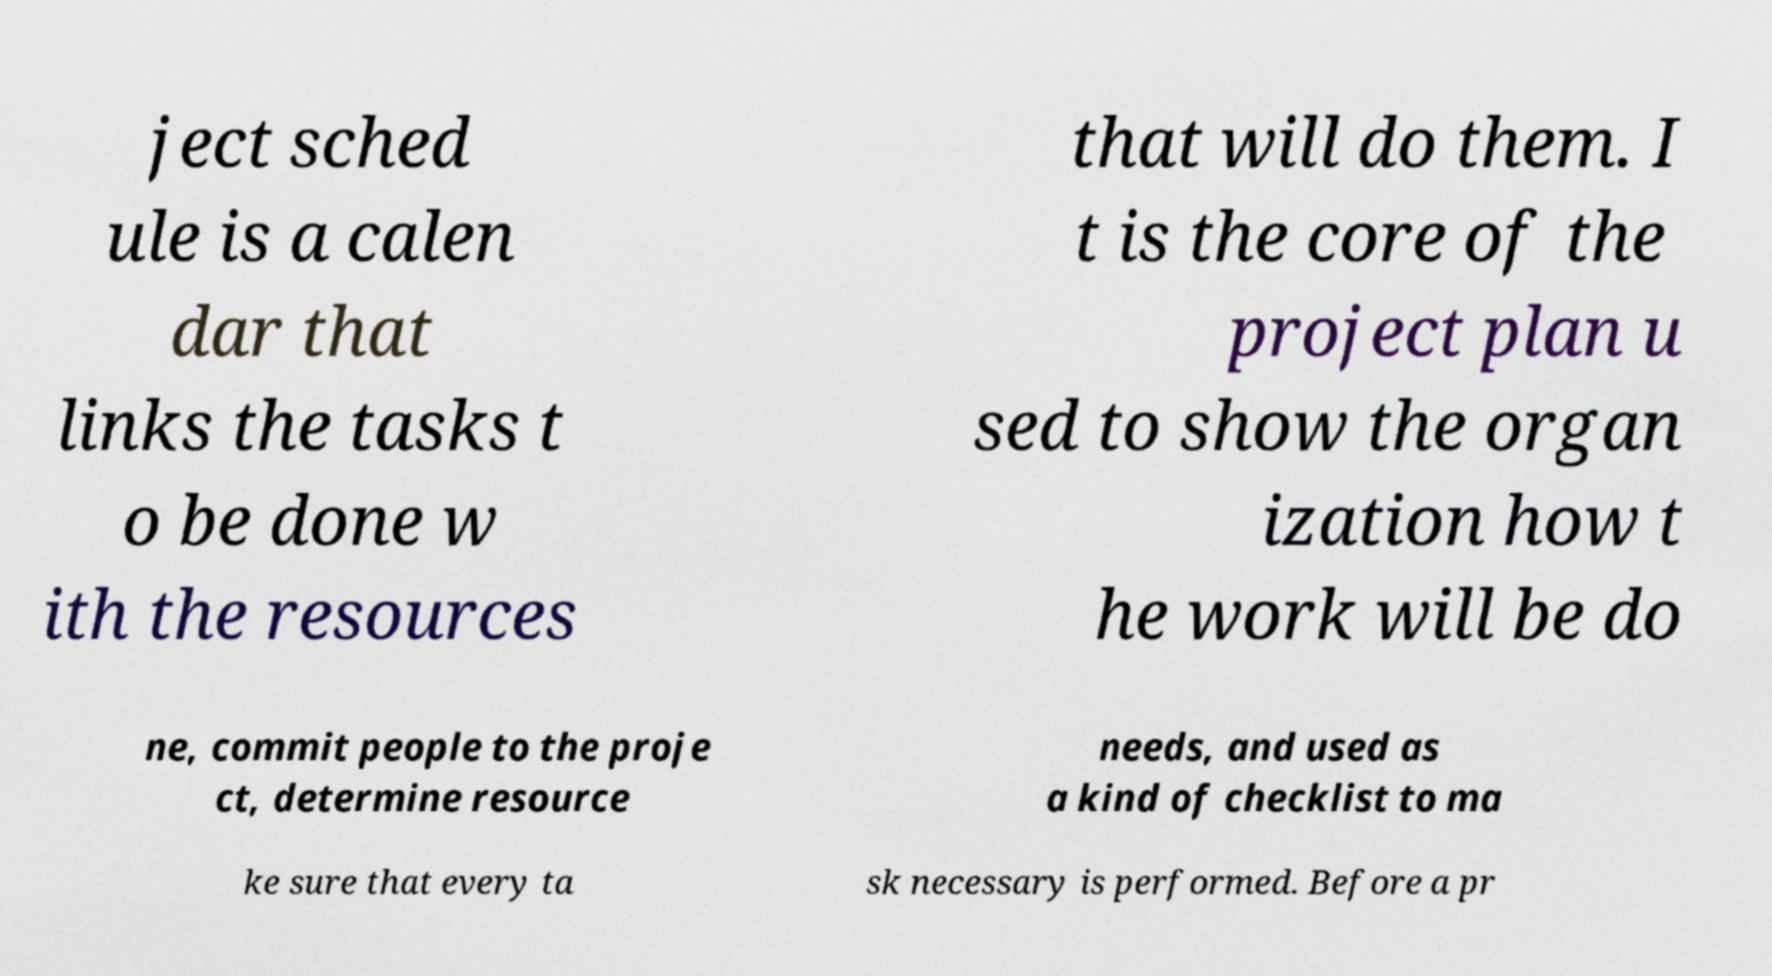What messages or text are displayed in this image? I need them in a readable, typed format. ject sched ule is a calen dar that links the tasks t o be done w ith the resources that will do them. I t is the core of the project plan u sed to show the organ ization how t he work will be do ne, commit people to the proje ct, determine resource needs, and used as a kind of checklist to ma ke sure that every ta sk necessary is performed. Before a pr 